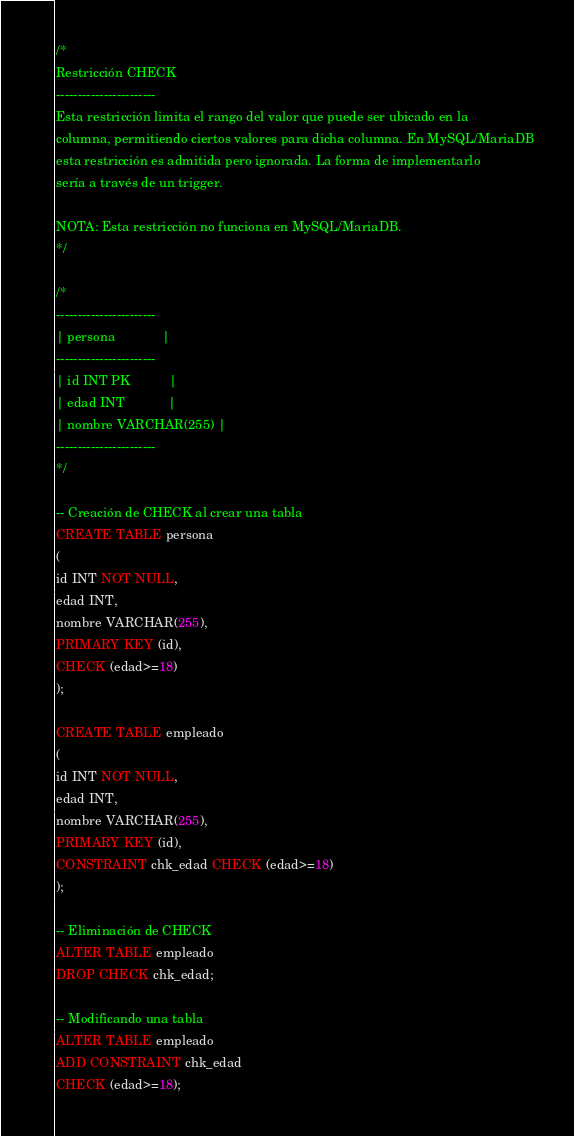<code> <loc_0><loc_0><loc_500><loc_500><_SQL_>/*
Restricción CHECK
-----------------------
Esta restricción limita el rango del valor que puede ser ubicado en la
columna, permitiendo ciertos valores para dicha columna. En MySQL/MariaDB
esta restricción es admitida pero ignorada. La forma de implementarlo
sería a través de un trigger.

NOTA: Esta restricción no funciona en MySQL/MariaDB.
*/

/*
-----------------------
| persona             |
-----------------------
| id INT PK           |
| edad INT            |
| nombre VARCHAR(255) |
-----------------------
*/

-- Creación de CHECK al crear una tabla
CREATE TABLE persona
(
id INT NOT NULL,
edad INT,
nombre VARCHAR(255),
PRIMARY KEY (id),
CHECK (edad>=18)
);

CREATE TABLE empleado
(
id INT NOT NULL,
edad INT,
nombre VARCHAR(255),
PRIMARY KEY (id),
CONSTRAINT chk_edad CHECK (edad>=18)
);

-- Eliminación de CHECK
ALTER TABLE empleado
DROP CHECK chk_edad;

-- Modificando una tabla
ALTER TABLE empleado
ADD CONSTRAINT chk_edad
CHECK (edad>=18);
</code> 